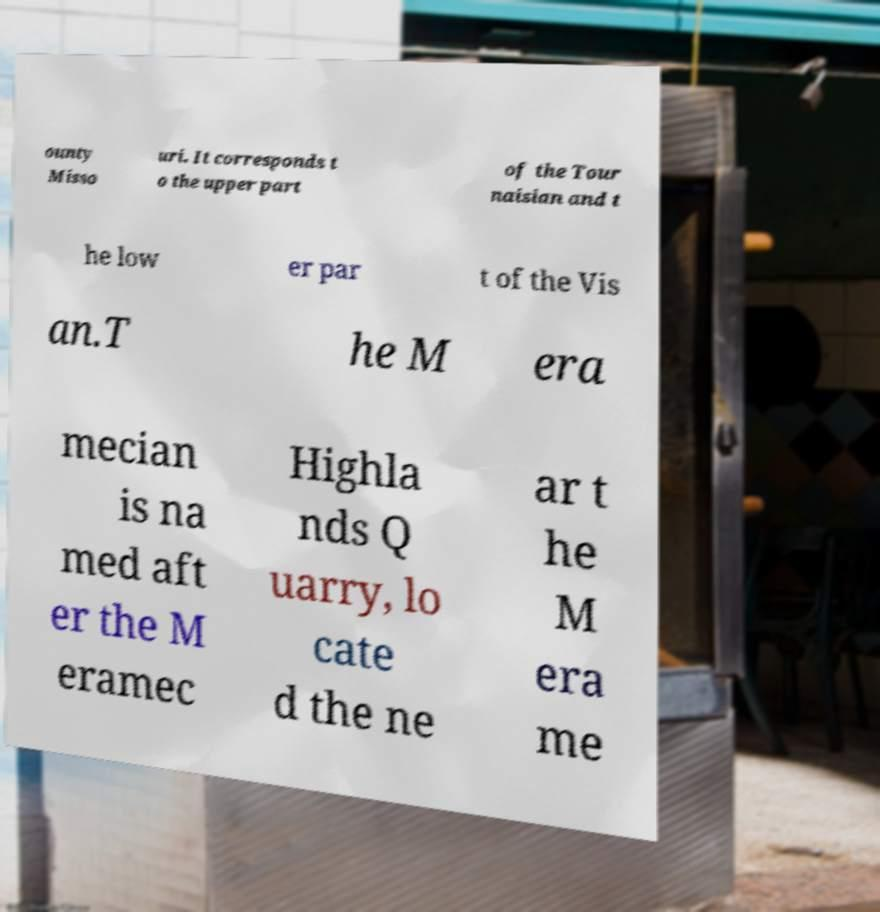There's text embedded in this image that I need extracted. Can you transcribe it verbatim? ounty Misso uri. It corresponds t o the upper part of the Tour naisian and t he low er par t of the Vis an.T he M era mecian is na med aft er the M eramec Highla nds Q uarry, lo cate d the ne ar t he M era me 